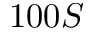<formula> <loc_0><loc_0><loc_500><loc_500>1 0 0 S</formula> 